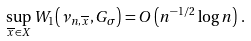<formula> <loc_0><loc_0><loc_500><loc_500>\sup _ { \overline { x } \in X } W _ { 1 } \left ( \nu _ { n , \overline { x } } , G _ { \sigma } \right ) = O \left ( n ^ { - 1 / 2 } \log n \right ) \, .</formula> 